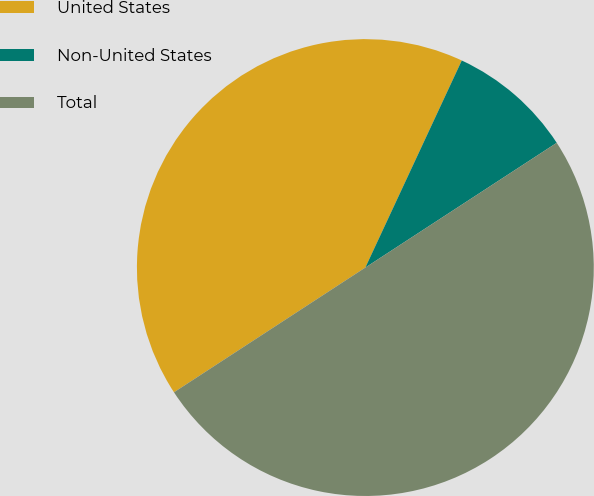Convert chart. <chart><loc_0><loc_0><loc_500><loc_500><pie_chart><fcel>United States<fcel>Non-United States<fcel>Total<nl><fcel>41.13%<fcel>8.87%<fcel>50.0%<nl></chart> 